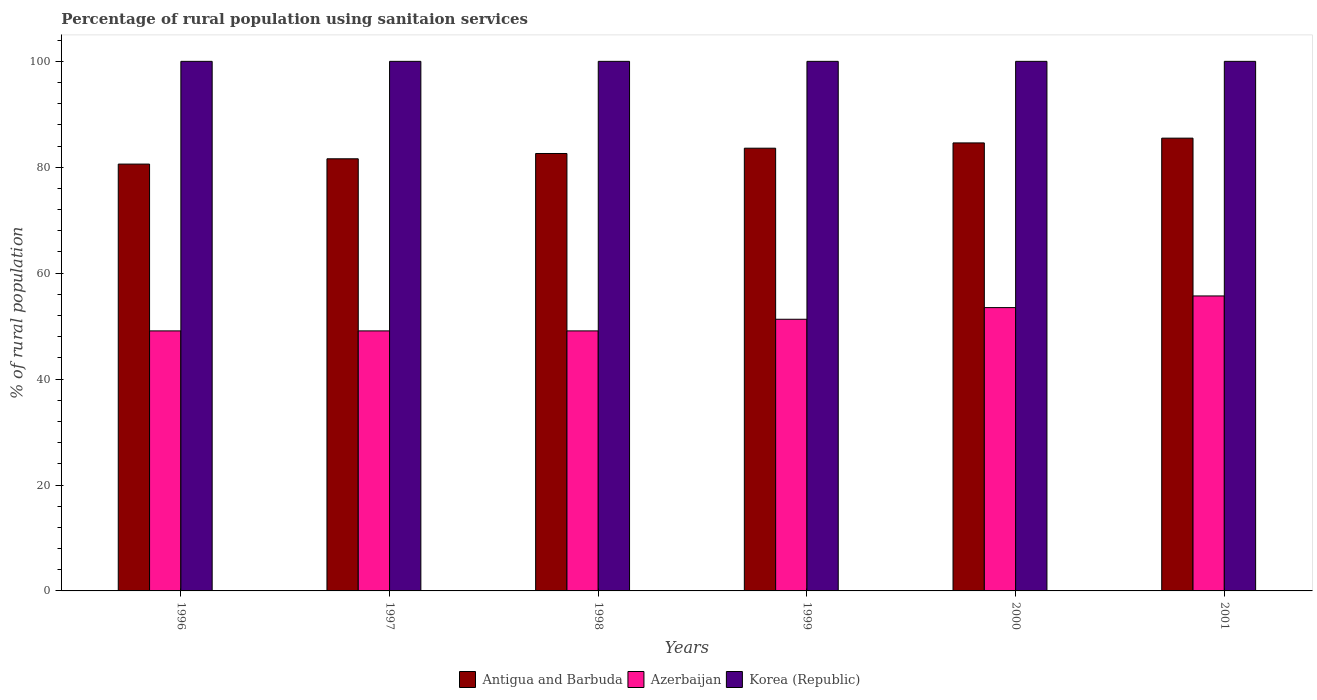How many different coloured bars are there?
Your answer should be compact. 3. Are the number of bars on each tick of the X-axis equal?
Offer a very short reply. Yes. How many bars are there on the 4th tick from the left?
Keep it short and to the point. 3. What is the label of the 1st group of bars from the left?
Keep it short and to the point. 1996. What is the percentage of rural population using sanitaion services in Antigua and Barbuda in 1997?
Keep it short and to the point. 81.6. Across all years, what is the maximum percentage of rural population using sanitaion services in Antigua and Barbuda?
Provide a succinct answer. 85.5. Across all years, what is the minimum percentage of rural population using sanitaion services in Korea (Republic)?
Ensure brevity in your answer.  100. In which year was the percentage of rural population using sanitaion services in Azerbaijan minimum?
Provide a short and direct response. 1996. What is the total percentage of rural population using sanitaion services in Korea (Republic) in the graph?
Your answer should be compact. 600. What is the difference between the percentage of rural population using sanitaion services in Antigua and Barbuda in 1998 and that in 1999?
Offer a very short reply. -1. What is the difference between the percentage of rural population using sanitaion services in Azerbaijan in 1999 and the percentage of rural population using sanitaion services in Antigua and Barbuda in 1996?
Offer a terse response. -29.3. What is the average percentage of rural population using sanitaion services in Korea (Republic) per year?
Offer a terse response. 100. In the year 1997, what is the difference between the percentage of rural population using sanitaion services in Korea (Republic) and percentage of rural population using sanitaion services in Azerbaijan?
Make the answer very short. 50.9. In how many years, is the percentage of rural population using sanitaion services in Antigua and Barbuda greater than 68 %?
Make the answer very short. 6. What is the ratio of the percentage of rural population using sanitaion services in Azerbaijan in 1998 to that in 1999?
Give a very brief answer. 0.96. Is the percentage of rural population using sanitaion services in Antigua and Barbuda in 1997 less than that in 2001?
Ensure brevity in your answer.  Yes. Is the difference between the percentage of rural population using sanitaion services in Korea (Republic) in 1996 and 2000 greater than the difference between the percentage of rural population using sanitaion services in Azerbaijan in 1996 and 2000?
Provide a short and direct response. Yes. What is the difference between the highest and the lowest percentage of rural population using sanitaion services in Azerbaijan?
Your response must be concise. 6.6. Is the sum of the percentage of rural population using sanitaion services in Antigua and Barbuda in 1999 and 2001 greater than the maximum percentage of rural population using sanitaion services in Korea (Republic) across all years?
Provide a short and direct response. Yes. What does the 1st bar from the left in 1996 represents?
Ensure brevity in your answer.  Antigua and Barbuda. What does the 3rd bar from the right in 1999 represents?
Provide a short and direct response. Antigua and Barbuda. Is it the case that in every year, the sum of the percentage of rural population using sanitaion services in Antigua and Barbuda and percentage of rural population using sanitaion services in Azerbaijan is greater than the percentage of rural population using sanitaion services in Korea (Republic)?
Your answer should be compact. Yes. Are all the bars in the graph horizontal?
Your answer should be very brief. No. How many years are there in the graph?
Your answer should be very brief. 6. What is the difference between two consecutive major ticks on the Y-axis?
Offer a terse response. 20. Does the graph contain grids?
Give a very brief answer. No. How many legend labels are there?
Offer a terse response. 3. How are the legend labels stacked?
Your response must be concise. Horizontal. What is the title of the graph?
Your answer should be compact. Percentage of rural population using sanitaion services. What is the label or title of the Y-axis?
Offer a terse response. % of rural population. What is the % of rural population of Antigua and Barbuda in 1996?
Offer a very short reply. 80.6. What is the % of rural population in Azerbaijan in 1996?
Your response must be concise. 49.1. What is the % of rural population in Antigua and Barbuda in 1997?
Your response must be concise. 81.6. What is the % of rural population of Azerbaijan in 1997?
Make the answer very short. 49.1. What is the % of rural population of Antigua and Barbuda in 1998?
Make the answer very short. 82.6. What is the % of rural population in Azerbaijan in 1998?
Provide a short and direct response. 49.1. What is the % of rural population of Korea (Republic) in 1998?
Keep it short and to the point. 100. What is the % of rural population in Antigua and Barbuda in 1999?
Your answer should be very brief. 83.6. What is the % of rural population in Azerbaijan in 1999?
Give a very brief answer. 51.3. What is the % of rural population in Korea (Republic) in 1999?
Keep it short and to the point. 100. What is the % of rural population in Antigua and Barbuda in 2000?
Ensure brevity in your answer.  84.6. What is the % of rural population in Azerbaijan in 2000?
Your answer should be very brief. 53.5. What is the % of rural population of Antigua and Barbuda in 2001?
Provide a succinct answer. 85.5. What is the % of rural population in Azerbaijan in 2001?
Your answer should be very brief. 55.7. Across all years, what is the maximum % of rural population of Antigua and Barbuda?
Your answer should be very brief. 85.5. Across all years, what is the maximum % of rural population of Azerbaijan?
Make the answer very short. 55.7. Across all years, what is the minimum % of rural population in Antigua and Barbuda?
Provide a short and direct response. 80.6. Across all years, what is the minimum % of rural population in Azerbaijan?
Provide a short and direct response. 49.1. Across all years, what is the minimum % of rural population in Korea (Republic)?
Your answer should be very brief. 100. What is the total % of rural population in Antigua and Barbuda in the graph?
Provide a succinct answer. 498.5. What is the total % of rural population in Azerbaijan in the graph?
Provide a short and direct response. 307.8. What is the total % of rural population in Korea (Republic) in the graph?
Your answer should be compact. 600. What is the difference between the % of rural population in Korea (Republic) in 1996 and that in 1997?
Keep it short and to the point. 0. What is the difference between the % of rural population of Antigua and Barbuda in 1996 and that in 1998?
Your answer should be compact. -2. What is the difference between the % of rural population of Azerbaijan in 1996 and that in 1998?
Your response must be concise. 0. What is the difference between the % of rural population in Antigua and Barbuda in 1996 and that in 1999?
Your answer should be compact. -3. What is the difference between the % of rural population in Korea (Republic) in 1996 and that in 1999?
Offer a terse response. 0. What is the difference between the % of rural population in Antigua and Barbuda in 1996 and that in 2000?
Your response must be concise. -4. What is the difference between the % of rural population of Azerbaijan in 1996 and that in 2000?
Give a very brief answer. -4.4. What is the difference between the % of rural population of Antigua and Barbuda in 1997 and that in 1998?
Provide a succinct answer. -1. What is the difference between the % of rural population of Azerbaijan in 1997 and that in 1998?
Provide a succinct answer. 0. What is the difference between the % of rural population of Korea (Republic) in 1997 and that in 1998?
Your answer should be compact. 0. What is the difference between the % of rural population of Azerbaijan in 1997 and that in 1999?
Give a very brief answer. -2.2. What is the difference between the % of rural population in Azerbaijan in 1997 and that in 2000?
Give a very brief answer. -4.4. What is the difference between the % of rural population of Korea (Republic) in 1997 and that in 2000?
Keep it short and to the point. 0. What is the difference between the % of rural population in Korea (Republic) in 1997 and that in 2001?
Provide a succinct answer. 0. What is the difference between the % of rural population in Antigua and Barbuda in 1998 and that in 1999?
Provide a succinct answer. -1. What is the difference between the % of rural population of Azerbaijan in 1998 and that in 1999?
Make the answer very short. -2.2. What is the difference between the % of rural population of Korea (Republic) in 1999 and that in 2000?
Provide a succinct answer. 0. What is the difference between the % of rural population of Azerbaijan in 1999 and that in 2001?
Your response must be concise. -4.4. What is the difference between the % of rural population in Korea (Republic) in 1999 and that in 2001?
Ensure brevity in your answer.  0. What is the difference between the % of rural population in Antigua and Barbuda in 2000 and that in 2001?
Your answer should be very brief. -0.9. What is the difference between the % of rural population in Antigua and Barbuda in 1996 and the % of rural population in Azerbaijan in 1997?
Provide a succinct answer. 31.5. What is the difference between the % of rural population of Antigua and Barbuda in 1996 and the % of rural population of Korea (Republic) in 1997?
Your answer should be very brief. -19.4. What is the difference between the % of rural population of Azerbaijan in 1996 and the % of rural population of Korea (Republic) in 1997?
Provide a short and direct response. -50.9. What is the difference between the % of rural population of Antigua and Barbuda in 1996 and the % of rural population of Azerbaijan in 1998?
Provide a succinct answer. 31.5. What is the difference between the % of rural population of Antigua and Barbuda in 1996 and the % of rural population of Korea (Republic) in 1998?
Keep it short and to the point. -19.4. What is the difference between the % of rural population of Azerbaijan in 1996 and the % of rural population of Korea (Republic) in 1998?
Offer a terse response. -50.9. What is the difference between the % of rural population in Antigua and Barbuda in 1996 and the % of rural population in Azerbaijan in 1999?
Provide a short and direct response. 29.3. What is the difference between the % of rural population of Antigua and Barbuda in 1996 and the % of rural population of Korea (Republic) in 1999?
Your response must be concise. -19.4. What is the difference between the % of rural population of Azerbaijan in 1996 and the % of rural population of Korea (Republic) in 1999?
Ensure brevity in your answer.  -50.9. What is the difference between the % of rural population in Antigua and Barbuda in 1996 and the % of rural population in Azerbaijan in 2000?
Keep it short and to the point. 27.1. What is the difference between the % of rural population of Antigua and Barbuda in 1996 and the % of rural population of Korea (Republic) in 2000?
Your answer should be compact. -19.4. What is the difference between the % of rural population of Azerbaijan in 1996 and the % of rural population of Korea (Republic) in 2000?
Keep it short and to the point. -50.9. What is the difference between the % of rural population of Antigua and Barbuda in 1996 and the % of rural population of Azerbaijan in 2001?
Your response must be concise. 24.9. What is the difference between the % of rural population in Antigua and Barbuda in 1996 and the % of rural population in Korea (Republic) in 2001?
Offer a terse response. -19.4. What is the difference between the % of rural population of Azerbaijan in 1996 and the % of rural population of Korea (Republic) in 2001?
Your response must be concise. -50.9. What is the difference between the % of rural population of Antigua and Barbuda in 1997 and the % of rural population of Azerbaijan in 1998?
Offer a terse response. 32.5. What is the difference between the % of rural population of Antigua and Barbuda in 1997 and the % of rural population of Korea (Republic) in 1998?
Provide a short and direct response. -18.4. What is the difference between the % of rural population of Azerbaijan in 1997 and the % of rural population of Korea (Republic) in 1998?
Your response must be concise. -50.9. What is the difference between the % of rural population of Antigua and Barbuda in 1997 and the % of rural population of Azerbaijan in 1999?
Provide a succinct answer. 30.3. What is the difference between the % of rural population of Antigua and Barbuda in 1997 and the % of rural population of Korea (Republic) in 1999?
Make the answer very short. -18.4. What is the difference between the % of rural population of Azerbaijan in 1997 and the % of rural population of Korea (Republic) in 1999?
Provide a short and direct response. -50.9. What is the difference between the % of rural population of Antigua and Barbuda in 1997 and the % of rural population of Azerbaijan in 2000?
Your response must be concise. 28.1. What is the difference between the % of rural population in Antigua and Barbuda in 1997 and the % of rural population in Korea (Republic) in 2000?
Give a very brief answer. -18.4. What is the difference between the % of rural population in Azerbaijan in 1997 and the % of rural population in Korea (Republic) in 2000?
Give a very brief answer. -50.9. What is the difference between the % of rural population in Antigua and Barbuda in 1997 and the % of rural population in Azerbaijan in 2001?
Ensure brevity in your answer.  25.9. What is the difference between the % of rural population in Antigua and Barbuda in 1997 and the % of rural population in Korea (Republic) in 2001?
Offer a very short reply. -18.4. What is the difference between the % of rural population in Azerbaijan in 1997 and the % of rural population in Korea (Republic) in 2001?
Give a very brief answer. -50.9. What is the difference between the % of rural population in Antigua and Barbuda in 1998 and the % of rural population in Azerbaijan in 1999?
Your response must be concise. 31.3. What is the difference between the % of rural population of Antigua and Barbuda in 1998 and the % of rural population of Korea (Republic) in 1999?
Make the answer very short. -17.4. What is the difference between the % of rural population of Azerbaijan in 1998 and the % of rural population of Korea (Republic) in 1999?
Your response must be concise. -50.9. What is the difference between the % of rural population of Antigua and Barbuda in 1998 and the % of rural population of Azerbaijan in 2000?
Provide a short and direct response. 29.1. What is the difference between the % of rural population in Antigua and Barbuda in 1998 and the % of rural population in Korea (Republic) in 2000?
Your response must be concise. -17.4. What is the difference between the % of rural population in Azerbaijan in 1998 and the % of rural population in Korea (Republic) in 2000?
Keep it short and to the point. -50.9. What is the difference between the % of rural population of Antigua and Barbuda in 1998 and the % of rural population of Azerbaijan in 2001?
Make the answer very short. 26.9. What is the difference between the % of rural population in Antigua and Barbuda in 1998 and the % of rural population in Korea (Republic) in 2001?
Ensure brevity in your answer.  -17.4. What is the difference between the % of rural population in Azerbaijan in 1998 and the % of rural population in Korea (Republic) in 2001?
Provide a succinct answer. -50.9. What is the difference between the % of rural population in Antigua and Barbuda in 1999 and the % of rural population in Azerbaijan in 2000?
Provide a succinct answer. 30.1. What is the difference between the % of rural population in Antigua and Barbuda in 1999 and the % of rural population in Korea (Republic) in 2000?
Offer a terse response. -16.4. What is the difference between the % of rural population in Azerbaijan in 1999 and the % of rural population in Korea (Republic) in 2000?
Your answer should be compact. -48.7. What is the difference between the % of rural population in Antigua and Barbuda in 1999 and the % of rural population in Azerbaijan in 2001?
Provide a short and direct response. 27.9. What is the difference between the % of rural population in Antigua and Barbuda in 1999 and the % of rural population in Korea (Republic) in 2001?
Make the answer very short. -16.4. What is the difference between the % of rural population in Azerbaijan in 1999 and the % of rural population in Korea (Republic) in 2001?
Offer a very short reply. -48.7. What is the difference between the % of rural population in Antigua and Barbuda in 2000 and the % of rural population in Azerbaijan in 2001?
Give a very brief answer. 28.9. What is the difference between the % of rural population in Antigua and Barbuda in 2000 and the % of rural population in Korea (Republic) in 2001?
Ensure brevity in your answer.  -15.4. What is the difference between the % of rural population in Azerbaijan in 2000 and the % of rural population in Korea (Republic) in 2001?
Your response must be concise. -46.5. What is the average % of rural population in Antigua and Barbuda per year?
Your answer should be very brief. 83.08. What is the average % of rural population of Azerbaijan per year?
Provide a short and direct response. 51.3. In the year 1996, what is the difference between the % of rural population of Antigua and Barbuda and % of rural population of Azerbaijan?
Your answer should be very brief. 31.5. In the year 1996, what is the difference between the % of rural population of Antigua and Barbuda and % of rural population of Korea (Republic)?
Make the answer very short. -19.4. In the year 1996, what is the difference between the % of rural population of Azerbaijan and % of rural population of Korea (Republic)?
Provide a succinct answer. -50.9. In the year 1997, what is the difference between the % of rural population of Antigua and Barbuda and % of rural population of Azerbaijan?
Ensure brevity in your answer.  32.5. In the year 1997, what is the difference between the % of rural population in Antigua and Barbuda and % of rural population in Korea (Republic)?
Your answer should be compact. -18.4. In the year 1997, what is the difference between the % of rural population of Azerbaijan and % of rural population of Korea (Republic)?
Your response must be concise. -50.9. In the year 1998, what is the difference between the % of rural population in Antigua and Barbuda and % of rural population in Azerbaijan?
Your answer should be very brief. 33.5. In the year 1998, what is the difference between the % of rural population of Antigua and Barbuda and % of rural population of Korea (Republic)?
Offer a terse response. -17.4. In the year 1998, what is the difference between the % of rural population in Azerbaijan and % of rural population in Korea (Republic)?
Offer a very short reply. -50.9. In the year 1999, what is the difference between the % of rural population in Antigua and Barbuda and % of rural population in Azerbaijan?
Give a very brief answer. 32.3. In the year 1999, what is the difference between the % of rural population in Antigua and Barbuda and % of rural population in Korea (Republic)?
Offer a very short reply. -16.4. In the year 1999, what is the difference between the % of rural population in Azerbaijan and % of rural population in Korea (Republic)?
Your answer should be very brief. -48.7. In the year 2000, what is the difference between the % of rural population in Antigua and Barbuda and % of rural population in Azerbaijan?
Your answer should be very brief. 31.1. In the year 2000, what is the difference between the % of rural population in Antigua and Barbuda and % of rural population in Korea (Republic)?
Provide a short and direct response. -15.4. In the year 2000, what is the difference between the % of rural population in Azerbaijan and % of rural population in Korea (Republic)?
Provide a succinct answer. -46.5. In the year 2001, what is the difference between the % of rural population of Antigua and Barbuda and % of rural population of Azerbaijan?
Make the answer very short. 29.8. In the year 2001, what is the difference between the % of rural population of Azerbaijan and % of rural population of Korea (Republic)?
Your answer should be compact. -44.3. What is the ratio of the % of rural population of Antigua and Barbuda in 1996 to that in 1998?
Your response must be concise. 0.98. What is the ratio of the % of rural population of Azerbaijan in 1996 to that in 1998?
Ensure brevity in your answer.  1. What is the ratio of the % of rural population of Antigua and Barbuda in 1996 to that in 1999?
Keep it short and to the point. 0.96. What is the ratio of the % of rural population of Azerbaijan in 1996 to that in 1999?
Keep it short and to the point. 0.96. What is the ratio of the % of rural population of Korea (Republic) in 1996 to that in 1999?
Keep it short and to the point. 1. What is the ratio of the % of rural population of Antigua and Barbuda in 1996 to that in 2000?
Your response must be concise. 0.95. What is the ratio of the % of rural population of Azerbaijan in 1996 to that in 2000?
Give a very brief answer. 0.92. What is the ratio of the % of rural population of Antigua and Barbuda in 1996 to that in 2001?
Give a very brief answer. 0.94. What is the ratio of the % of rural population in Azerbaijan in 1996 to that in 2001?
Make the answer very short. 0.88. What is the ratio of the % of rural population of Korea (Republic) in 1996 to that in 2001?
Give a very brief answer. 1. What is the ratio of the % of rural population of Antigua and Barbuda in 1997 to that in 1998?
Provide a succinct answer. 0.99. What is the ratio of the % of rural population of Azerbaijan in 1997 to that in 1998?
Your response must be concise. 1. What is the ratio of the % of rural population in Korea (Republic) in 1997 to that in 1998?
Ensure brevity in your answer.  1. What is the ratio of the % of rural population of Antigua and Barbuda in 1997 to that in 1999?
Keep it short and to the point. 0.98. What is the ratio of the % of rural population of Azerbaijan in 1997 to that in 1999?
Offer a very short reply. 0.96. What is the ratio of the % of rural population of Antigua and Barbuda in 1997 to that in 2000?
Ensure brevity in your answer.  0.96. What is the ratio of the % of rural population in Azerbaijan in 1997 to that in 2000?
Offer a very short reply. 0.92. What is the ratio of the % of rural population of Korea (Republic) in 1997 to that in 2000?
Your answer should be very brief. 1. What is the ratio of the % of rural population of Antigua and Barbuda in 1997 to that in 2001?
Ensure brevity in your answer.  0.95. What is the ratio of the % of rural population in Azerbaijan in 1997 to that in 2001?
Your response must be concise. 0.88. What is the ratio of the % of rural population in Antigua and Barbuda in 1998 to that in 1999?
Provide a succinct answer. 0.99. What is the ratio of the % of rural population of Azerbaijan in 1998 to that in 1999?
Give a very brief answer. 0.96. What is the ratio of the % of rural population in Antigua and Barbuda in 1998 to that in 2000?
Offer a terse response. 0.98. What is the ratio of the % of rural population of Azerbaijan in 1998 to that in 2000?
Your answer should be compact. 0.92. What is the ratio of the % of rural population in Antigua and Barbuda in 1998 to that in 2001?
Provide a succinct answer. 0.97. What is the ratio of the % of rural population of Azerbaijan in 1998 to that in 2001?
Your response must be concise. 0.88. What is the ratio of the % of rural population of Korea (Republic) in 1998 to that in 2001?
Provide a short and direct response. 1. What is the ratio of the % of rural population of Azerbaijan in 1999 to that in 2000?
Your answer should be very brief. 0.96. What is the ratio of the % of rural population in Antigua and Barbuda in 1999 to that in 2001?
Make the answer very short. 0.98. What is the ratio of the % of rural population of Azerbaijan in 1999 to that in 2001?
Your response must be concise. 0.92. What is the ratio of the % of rural population in Antigua and Barbuda in 2000 to that in 2001?
Your answer should be very brief. 0.99. What is the ratio of the % of rural population in Azerbaijan in 2000 to that in 2001?
Your answer should be very brief. 0.96. What is the ratio of the % of rural population in Korea (Republic) in 2000 to that in 2001?
Ensure brevity in your answer.  1. 